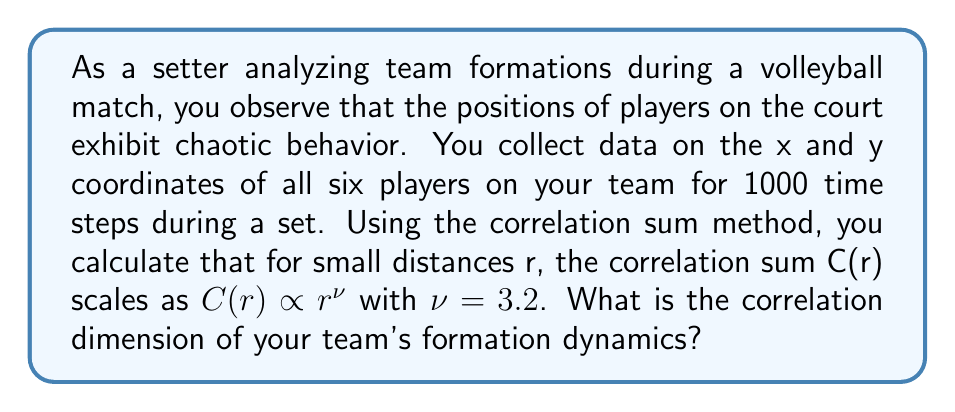Teach me how to tackle this problem. To solve this problem, we need to understand the concept of correlation dimension in chaos theory and how it relates to the scaling behavior of the correlation sum.

1. The correlation dimension is a measure of the dimensionality of the space occupied by a set of random points, often used to characterize chaotic attractors.

2. It is defined as the exponent $\nu$ in the scaling relation of the correlation sum:

   $$C(r) \propto r^{\nu}$$

   where C(r) is the correlation sum and r is the distance.

3. In this case, we are given that $\nu = 3.2$.

4. The correlation dimension $D_2$ is directly equal to this scaling exponent $\nu$.

5. Therefore, the correlation dimension of the team's formation dynamics is:

   $$D_2 = \nu = 3.2$$

This non-integer dimension suggests that the team's formations exhibit fractal-like properties, which is characteristic of chaotic systems.
Answer: $D_2 = 3.2$ 